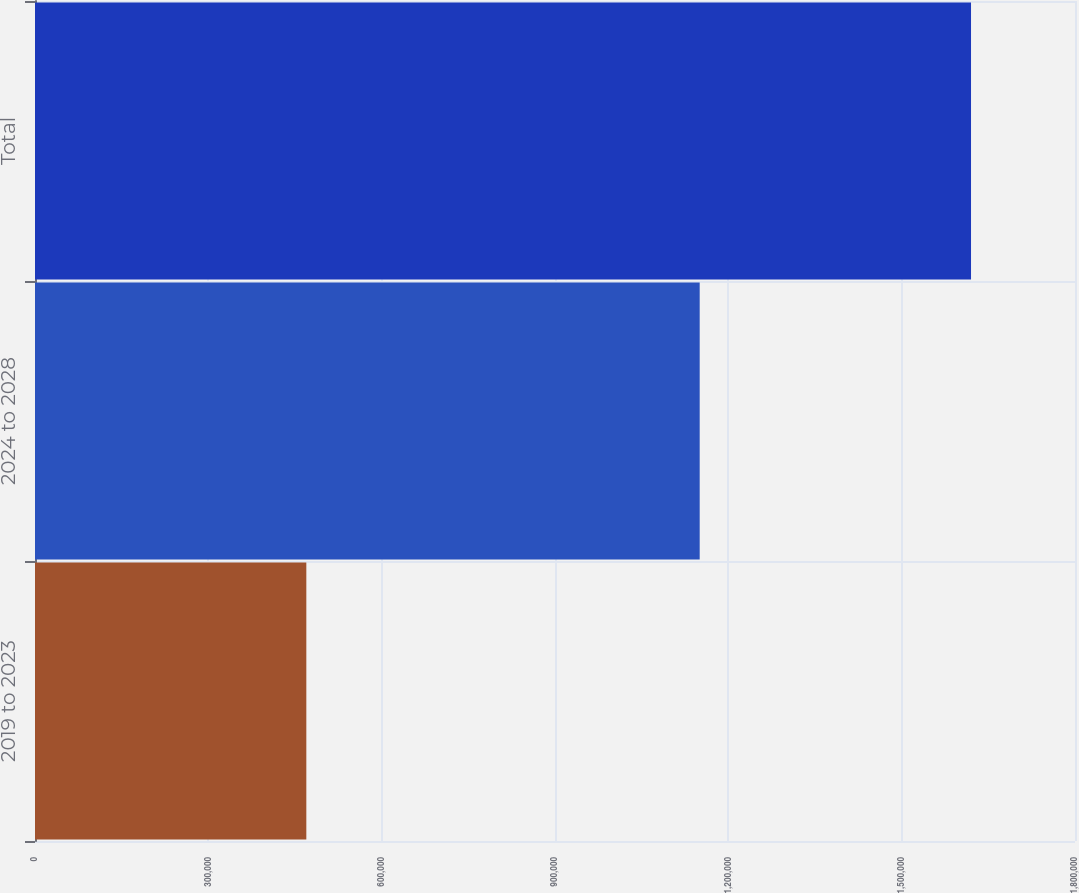Convert chart. <chart><loc_0><loc_0><loc_500><loc_500><bar_chart><fcel>2019 to 2023<fcel>2024 to 2028<fcel>Total<nl><fcel>469600<fcel>1.15044e+06<fcel>1.62004e+06<nl></chart> 